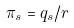<formula> <loc_0><loc_0><loc_500><loc_500>\pi _ { s } = q _ { s } / r</formula> 